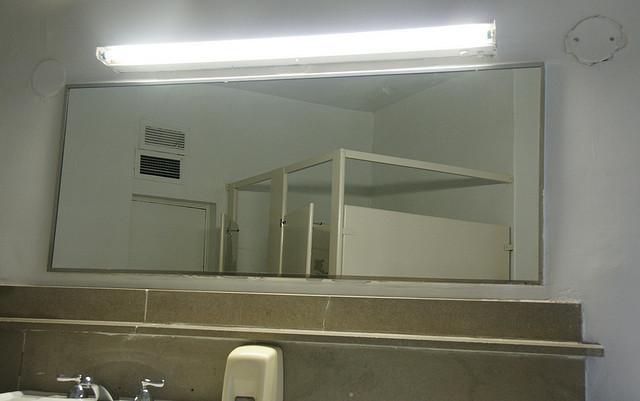How many yellow car in the road?
Give a very brief answer. 0. 